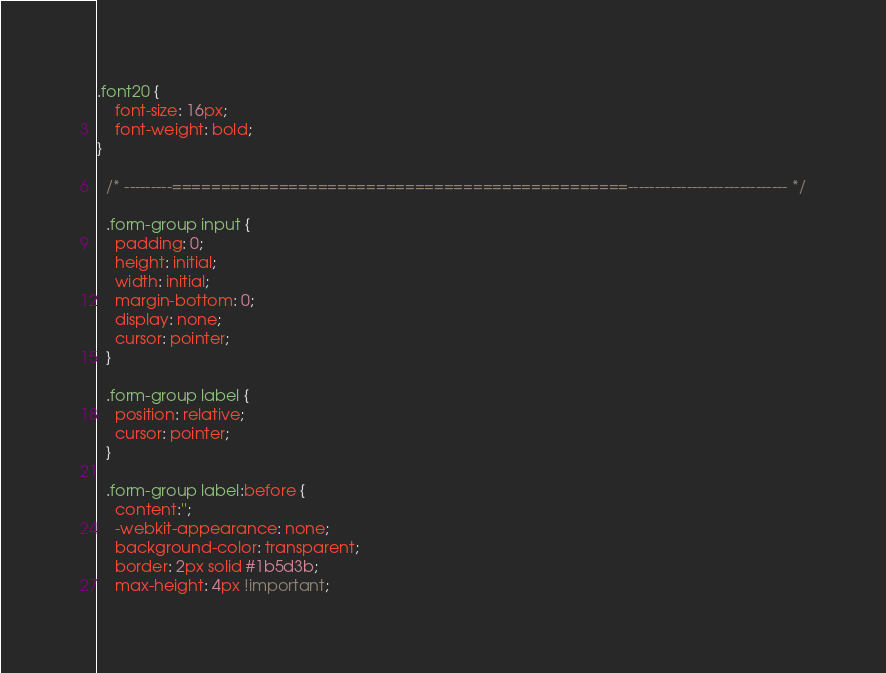<code> <loc_0><loc_0><loc_500><loc_500><_CSS_>
.font20 {
    font-size: 16px;
    font-weight: bold;
}

  /* ---------===============================================------------------------------ */
  
  .form-group input {
    padding: 0;
    height: initial;
    width: initial;
    margin-bottom: 0;
    display: none;
    cursor: pointer;
  }
  
  .form-group label {
    position: relative;
    cursor: pointer;
  }
  
  .form-group label:before {
    content:'';
    -webkit-appearance: none;
    background-color: transparent;
    border: 2px solid #1b5d3b;
    max-height: 4px !important;</code> 